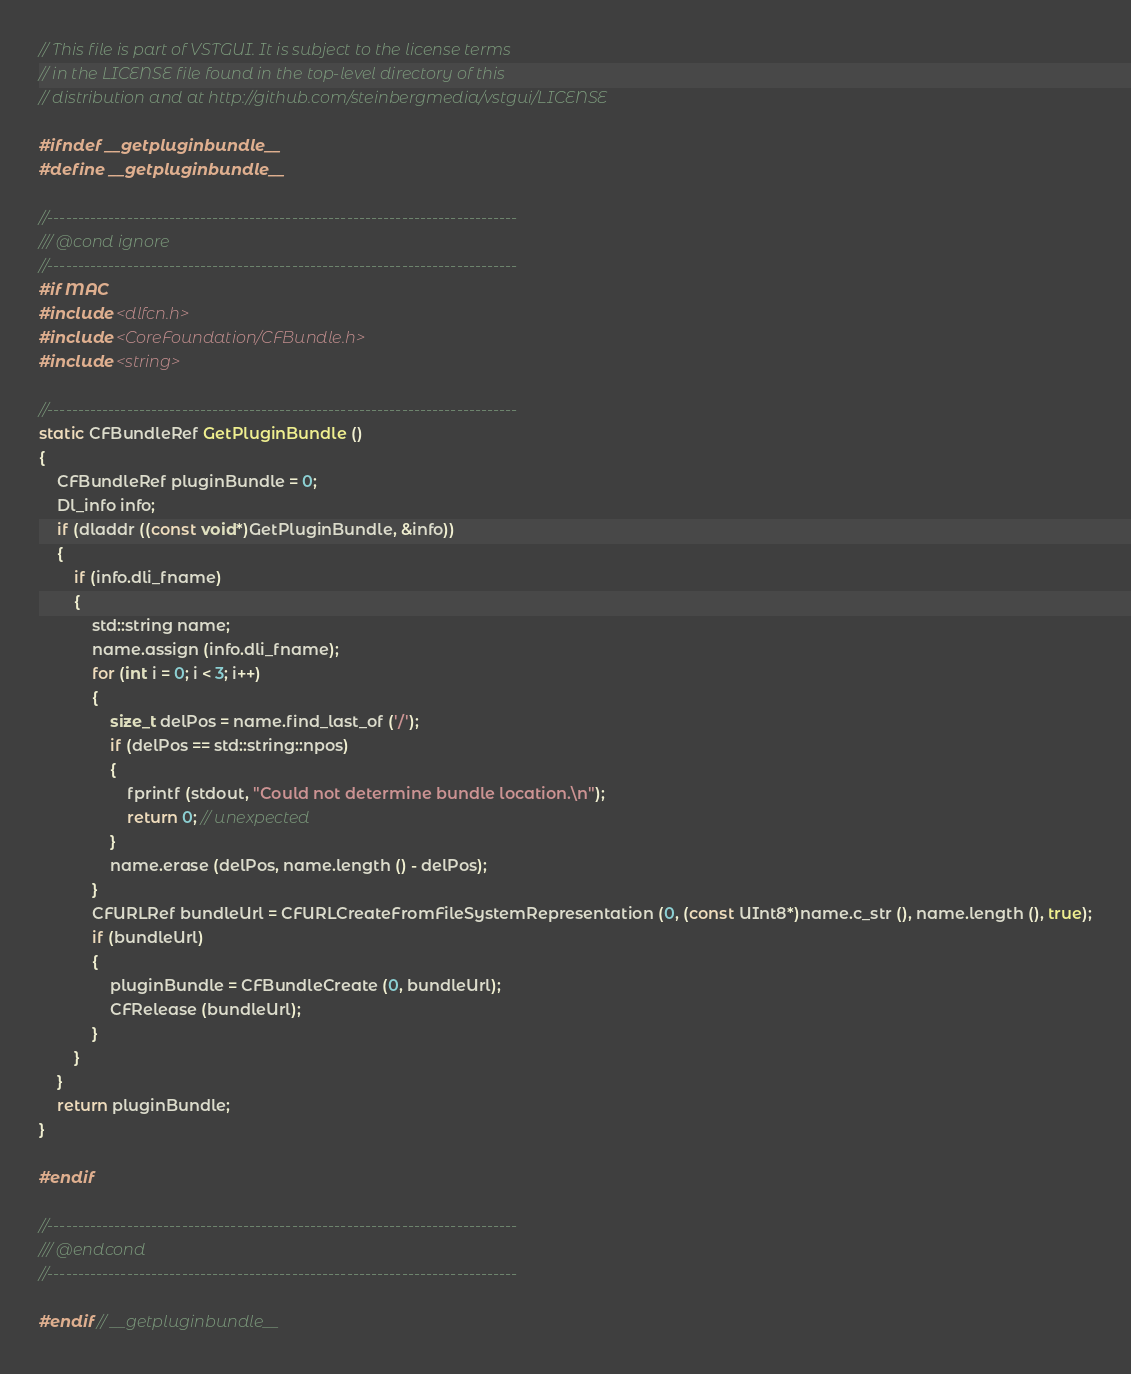<code> <loc_0><loc_0><loc_500><loc_500><_C_>// This file is part of VSTGUI. It is subject to the license terms 
// in the LICENSE file found in the top-level directory of this
// distribution and at http://github.com/steinbergmedia/vstgui/LICENSE

#ifndef __getpluginbundle__
#define __getpluginbundle__

//-----------------------------------------------------------------------------
/// @cond ignore
//-----------------------------------------------------------------------------
#if MAC
#include <dlfcn.h>
#include <CoreFoundation/CFBundle.h>
#include <string>

//-----------------------------------------------------------------------------
static CFBundleRef GetPluginBundle ()
{
	CFBundleRef pluginBundle = 0;
	Dl_info info;
	if (dladdr ((const void*)GetPluginBundle, &info))
	{
		if (info.dli_fname)
		{
			std::string name;
			name.assign (info.dli_fname);
			for (int i = 0; i < 3; i++)
			{
				size_t delPos = name.find_last_of ('/');
				if (delPos == std::string::npos)
				{
					fprintf (stdout, "Could not determine bundle location.\n");
					return 0; // unexpected
				}
				name.erase (delPos, name.length () - delPos);
			}
			CFURLRef bundleUrl = CFURLCreateFromFileSystemRepresentation (0, (const UInt8*)name.c_str (), name.length (), true);
			if (bundleUrl)
			{
				pluginBundle = CFBundleCreate (0, bundleUrl);
				CFRelease (bundleUrl);
			}
		}
	}
	return pluginBundle;
}

#endif

//-----------------------------------------------------------------------------
/// @endcond
//-----------------------------------------------------------------------------

#endif // __getpluginbundle__
</code> 